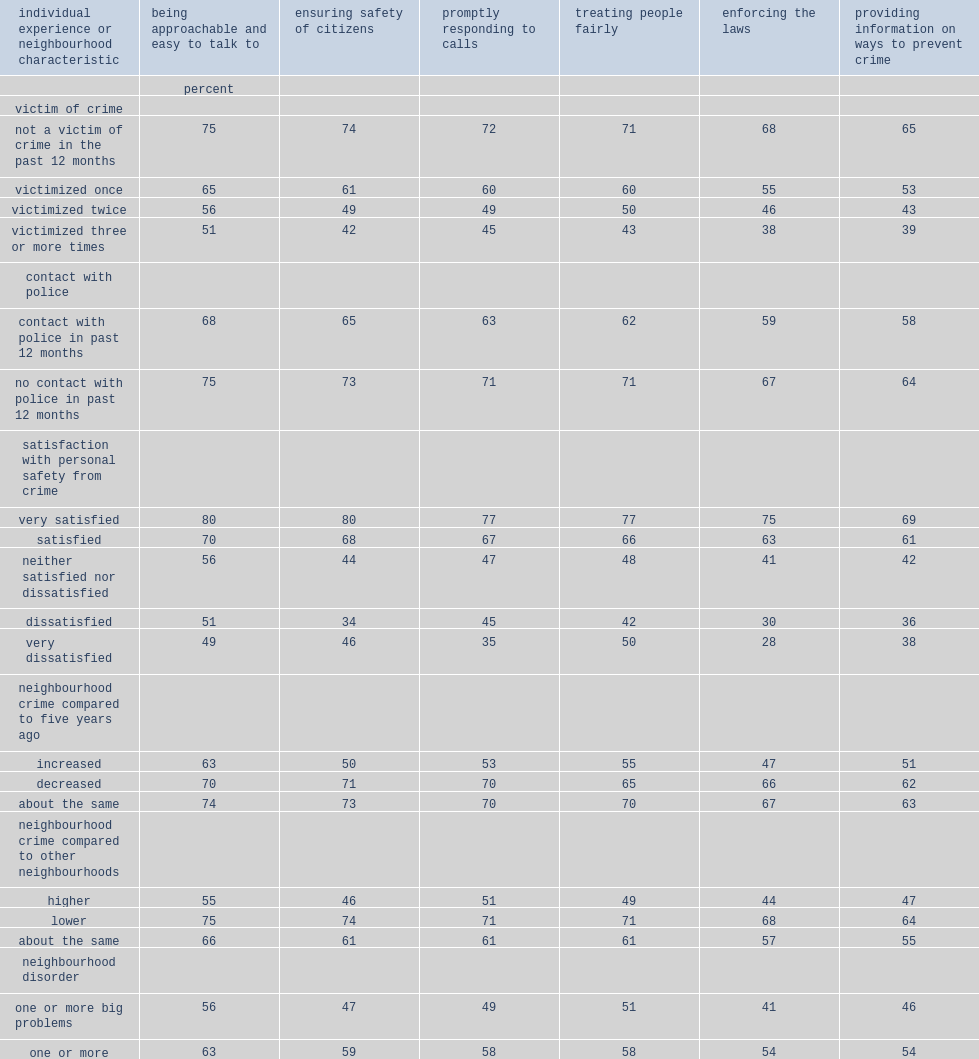What level of satisfaction for canadians who report a high level of satisfaction with their personal safety from crime rate police performance higher in all categories compared to those who are less satisfied? Very satisfied. What percent of canadians who were very satisfied believed police are doing a good job enforcing the laws? 75.0. 